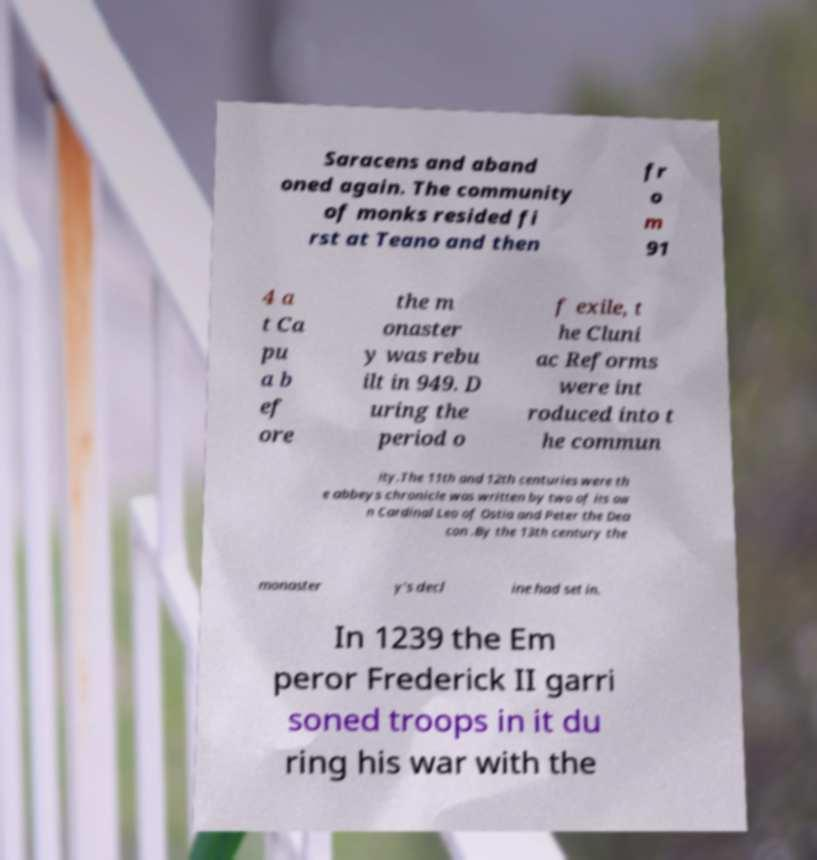Can you accurately transcribe the text from the provided image for me? Saracens and aband oned again. The community of monks resided fi rst at Teano and then fr o m 91 4 a t Ca pu a b ef ore the m onaster y was rebu ilt in 949. D uring the period o f exile, t he Cluni ac Reforms were int roduced into t he commun ity.The 11th and 12th centuries were th e abbeys chronicle was written by two of its ow n Cardinal Leo of Ostia and Peter the Dea con .By the 13th century the monaster y's decl ine had set in. In 1239 the Em peror Frederick II garri soned troops in it du ring his war with the 